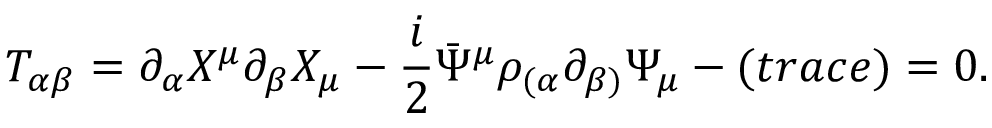<formula> <loc_0><loc_0><loc_500><loc_500>T _ { \alpha \beta } = \partial _ { \alpha } X ^ { \mu } \partial _ { \beta } X _ { \mu } - \frac { i } { 2 } \bar { \Psi } ^ { \mu } \rho _ { ( \alpha } \partial _ { \beta ) } \Psi _ { \mu } - ( t r a c e ) = 0 .</formula> 